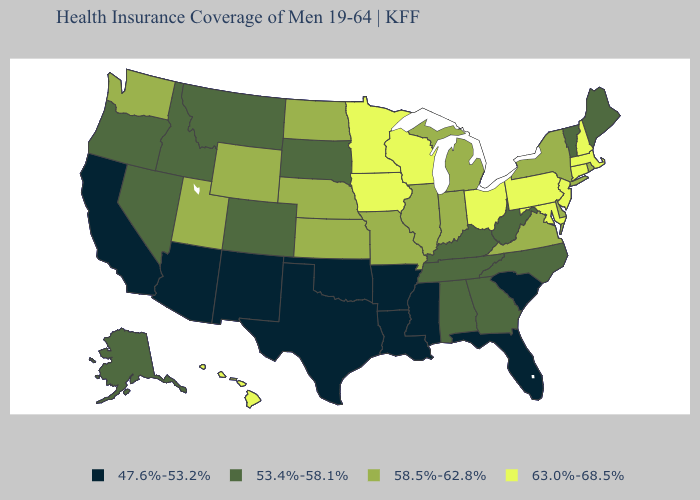What is the value of Georgia?
Answer briefly. 53.4%-58.1%. Does Arkansas have the lowest value in the South?
Short answer required. Yes. Which states have the highest value in the USA?
Answer briefly. Connecticut, Hawaii, Iowa, Maryland, Massachusetts, Minnesota, New Hampshire, New Jersey, Ohio, Pennsylvania, Wisconsin. Name the states that have a value in the range 53.4%-58.1%?
Quick response, please. Alabama, Alaska, Colorado, Georgia, Idaho, Kentucky, Maine, Montana, Nevada, North Carolina, Oregon, South Dakota, Tennessee, Vermont, West Virginia. What is the highest value in states that border Utah?
Short answer required. 58.5%-62.8%. Does the map have missing data?
Answer briefly. No. Name the states that have a value in the range 63.0%-68.5%?
Answer briefly. Connecticut, Hawaii, Iowa, Maryland, Massachusetts, Minnesota, New Hampshire, New Jersey, Ohio, Pennsylvania, Wisconsin. Does Wyoming have a higher value than Pennsylvania?
Give a very brief answer. No. Which states have the lowest value in the USA?
Be succinct. Arizona, Arkansas, California, Florida, Louisiana, Mississippi, New Mexico, Oklahoma, South Carolina, Texas. What is the value of Idaho?
Be succinct. 53.4%-58.1%. Name the states that have a value in the range 63.0%-68.5%?
Short answer required. Connecticut, Hawaii, Iowa, Maryland, Massachusetts, Minnesota, New Hampshire, New Jersey, Ohio, Pennsylvania, Wisconsin. Name the states that have a value in the range 63.0%-68.5%?
Answer briefly. Connecticut, Hawaii, Iowa, Maryland, Massachusetts, Minnesota, New Hampshire, New Jersey, Ohio, Pennsylvania, Wisconsin. Among the states that border Arizona , which have the highest value?
Concise answer only. Utah. What is the value of New Hampshire?
Give a very brief answer. 63.0%-68.5%. Does the first symbol in the legend represent the smallest category?
Keep it brief. Yes. 